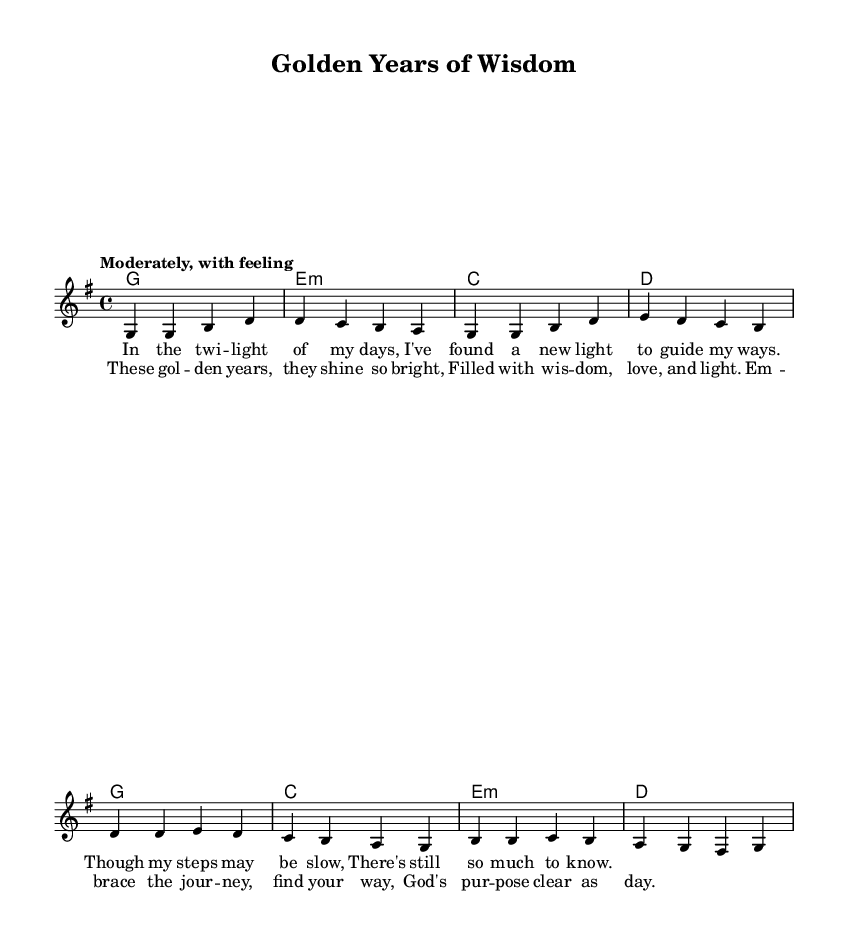What is the key signature of this music? The key signature is G major, which has one sharp (F#) indicated on the staff.
Answer: G major What is the time signature of this music? The time signature is found in the beginning of the sheet music, stating 4/4, which means four beats per measure.
Answer: 4/4 What is the indicated tempo for this piece? The tempo is marked as "Moderately, with feeling," indicating a moderate pace.
Answer: Moderately, with feeling How many measures are in the verse? The verse consists of four measures, as indicated by the distinct phrases laid out on the staff.
Answer: Four What is the first line of the lyrics in the verse? The first line of the lyrics in the verse is shown directly below the melody, stating "In the twi -- light of my days."
Answer: In the twi -- light of my days What is the emotional theme of the chorus? The chorus expresses an uplifting sentiment, emphasizing the brightness and wisdom found in later years, encapsulated in phrases like "These gol -- den years, they shine so bright."
Answer: Uplifting How many chords are used in the chorus? The chorus features four chords as represented in the chord mode underneath, which correspond to the melody and lyrics sung during this section.
Answer: Four 